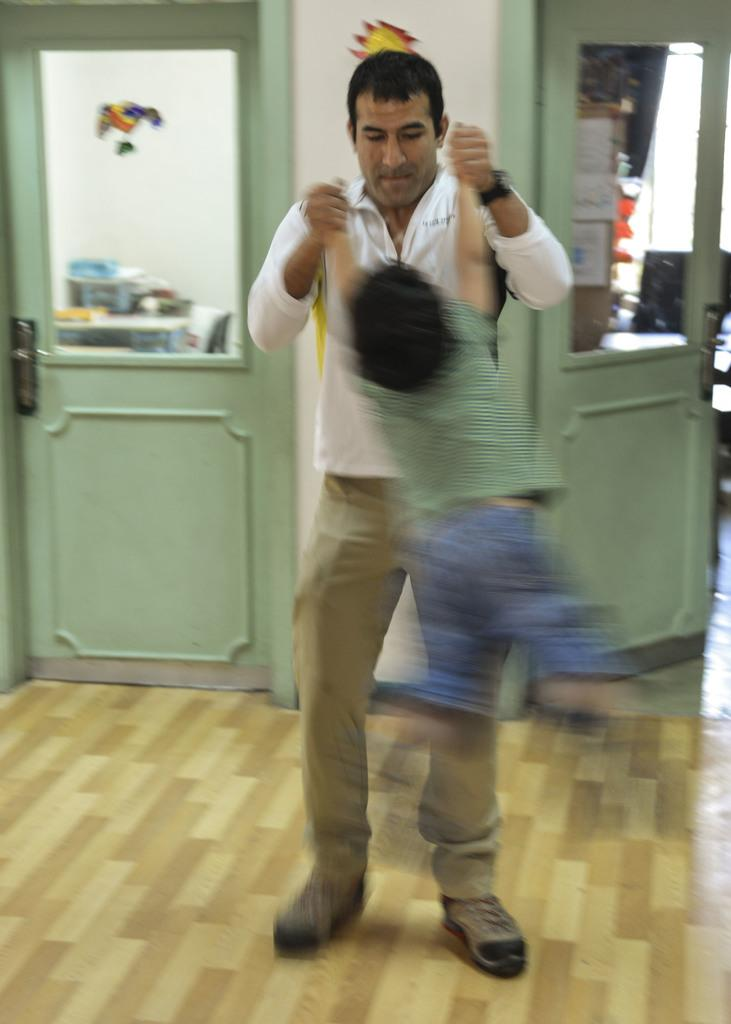What is the person in the image doing? The person is holding a child in the image. What architectural feature can be seen in the image? There are doors visible in the image. What can be seen through the doors? Objects are visible through the doors. What decorative elements are present in the image? There is a craft on the door and a craft on the wall. How many beds are visible in the image? There are no beds visible in the image. What time of day is it in the image? The time of day cannot be determined from the image. 